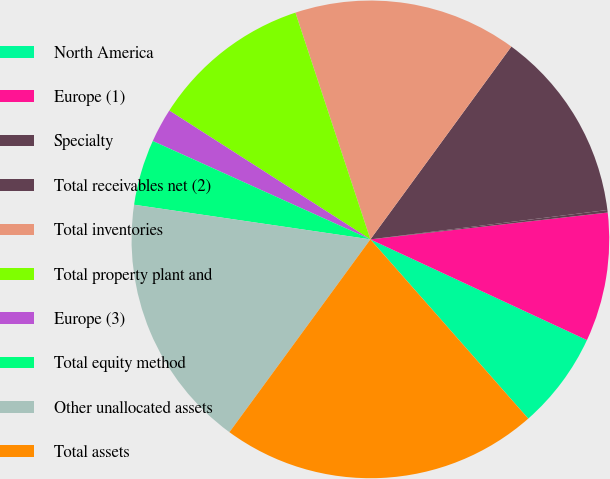<chart> <loc_0><loc_0><loc_500><loc_500><pie_chart><fcel>North America<fcel>Europe (1)<fcel>Specialty<fcel>Total receivables net (2)<fcel>Total inventories<fcel>Total property plant and<fcel>Europe (3)<fcel>Total equity method<fcel>Other unallocated assets<fcel>Total assets<nl><fcel>6.58%<fcel>8.72%<fcel>0.17%<fcel>12.99%<fcel>15.13%<fcel>10.85%<fcel>2.31%<fcel>4.44%<fcel>17.27%<fcel>21.54%<nl></chart> 